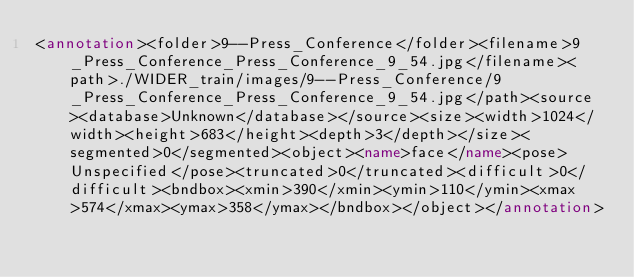<code> <loc_0><loc_0><loc_500><loc_500><_XML_><annotation><folder>9--Press_Conference</folder><filename>9_Press_Conference_Press_Conference_9_54.jpg</filename><path>./WIDER_train/images/9--Press_Conference/9_Press_Conference_Press_Conference_9_54.jpg</path><source><database>Unknown</database></source><size><width>1024</width><height>683</height><depth>3</depth></size><segmented>0</segmented><object><name>face</name><pose>Unspecified</pose><truncated>0</truncated><difficult>0</difficult><bndbox><xmin>390</xmin><ymin>110</ymin><xmax>574</xmax><ymax>358</ymax></bndbox></object></annotation></code> 